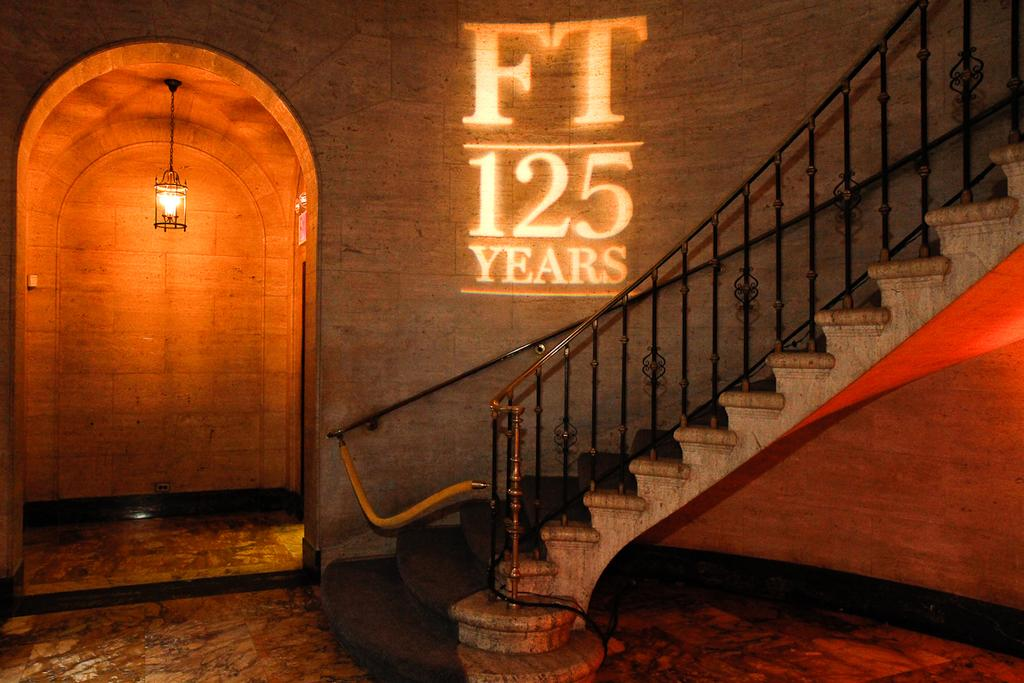What type of structure is present in the image? There is a staircase with a metal rod fence in the image. What can be seen on the wall in the image? There is a display text on the wall. What type of lighting is present in the image? A lamp is hanging from the ceiling behind the text. How many crows are perched on the metal rod fence in the image? There are no crows present in the image; it only features a staircase with a metal rod fence, a display text on the wall, and a lamp hanging from the ceiling. 